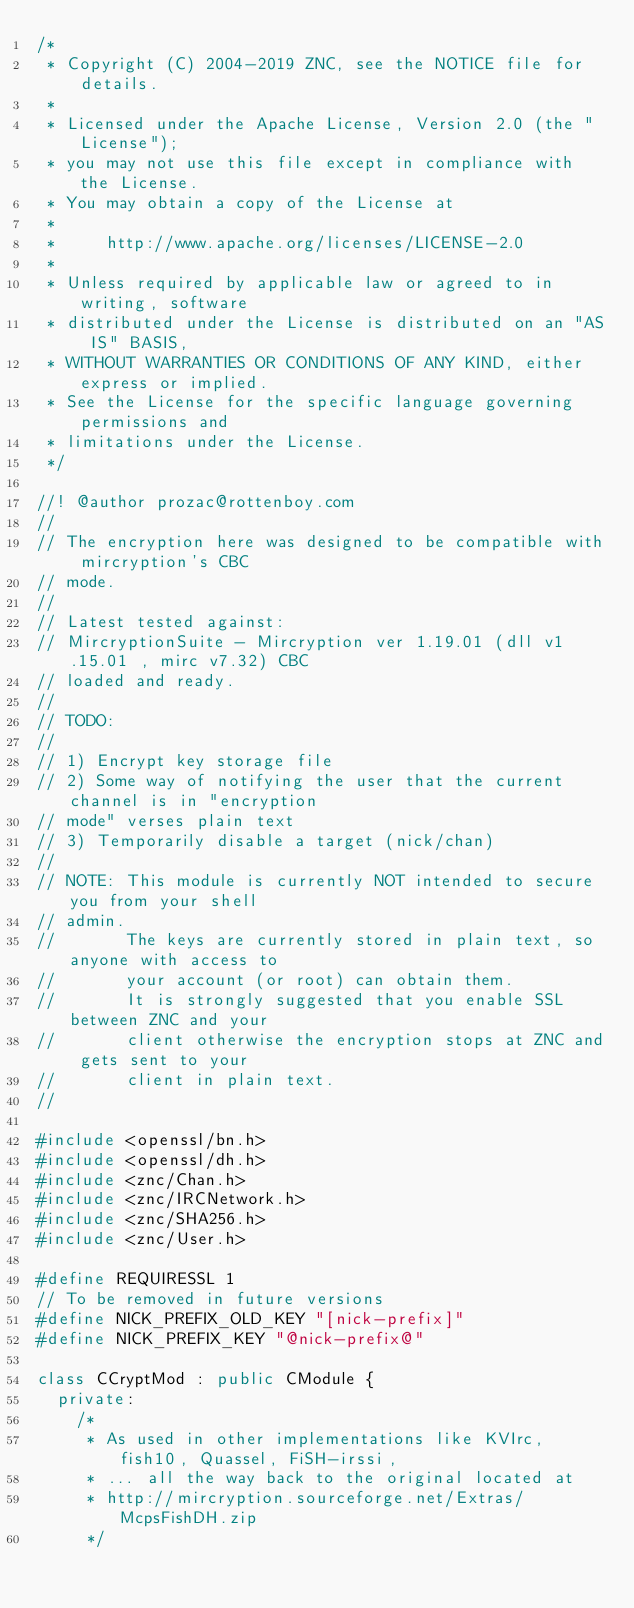Convert code to text. <code><loc_0><loc_0><loc_500><loc_500><_C++_>/*
 * Copyright (C) 2004-2019 ZNC, see the NOTICE file for details.
 *
 * Licensed under the Apache License, Version 2.0 (the "License");
 * you may not use this file except in compliance with the License.
 * You may obtain a copy of the License at
 *
 *     http://www.apache.org/licenses/LICENSE-2.0
 *
 * Unless required by applicable law or agreed to in writing, software
 * distributed under the License is distributed on an "AS IS" BASIS,
 * WITHOUT WARRANTIES OR CONDITIONS OF ANY KIND, either express or implied.
 * See the License for the specific language governing permissions and
 * limitations under the License.
 */

//! @author prozac@rottenboy.com
//
// The encryption here was designed to be compatible with mircryption's CBC
// mode.
//
// Latest tested against:
// MircryptionSuite - Mircryption ver 1.19.01 (dll v1.15.01 , mirc v7.32) CBC
// loaded and ready.
//
// TODO:
//
// 1) Encrypt key storage file
// 2) Some way of notifying the user that the current channel is in "encryption
// mode" verses plain text
// 3) Temporarily disable a target (nick/chan)
//
// NOTE: This module is currently NOT intended to secure you from your shell
// admin.
//       The keys are currently stored in plain text, so anyone with access to
//       your account (or root) can obtain them.
//       It is strongly suggested that you enable SSL between ZNC and your
//       client otherwise the encryption stops at ZNC and gets sent to your
//       client in plain text.
//

#include <openssl/bn.h>
#include <openssl/dh.h>
#include <znc/Chan.h>
#include <znc/IRCNetwork.h>
#include <znc/SHA256.h>
#include <znc/User.h>

#define REQUIRESSL 1
// To be removed in future versions
#define NICK_PREFIX_OLD_KEY "[nick-prefix]"
#define NICK_PREFIX_KEY "@nick-prefix@"

class CCryptMod : public CModule {
  private:
    /*
     * As used in other implementations like KVIrc, fish10, Quassel, FiSH-irssi,
     * ... all the way back to the original located at
     * http://mircryption.sourceforge.net/Extras/McpsFishDH.zip
     */</code> 